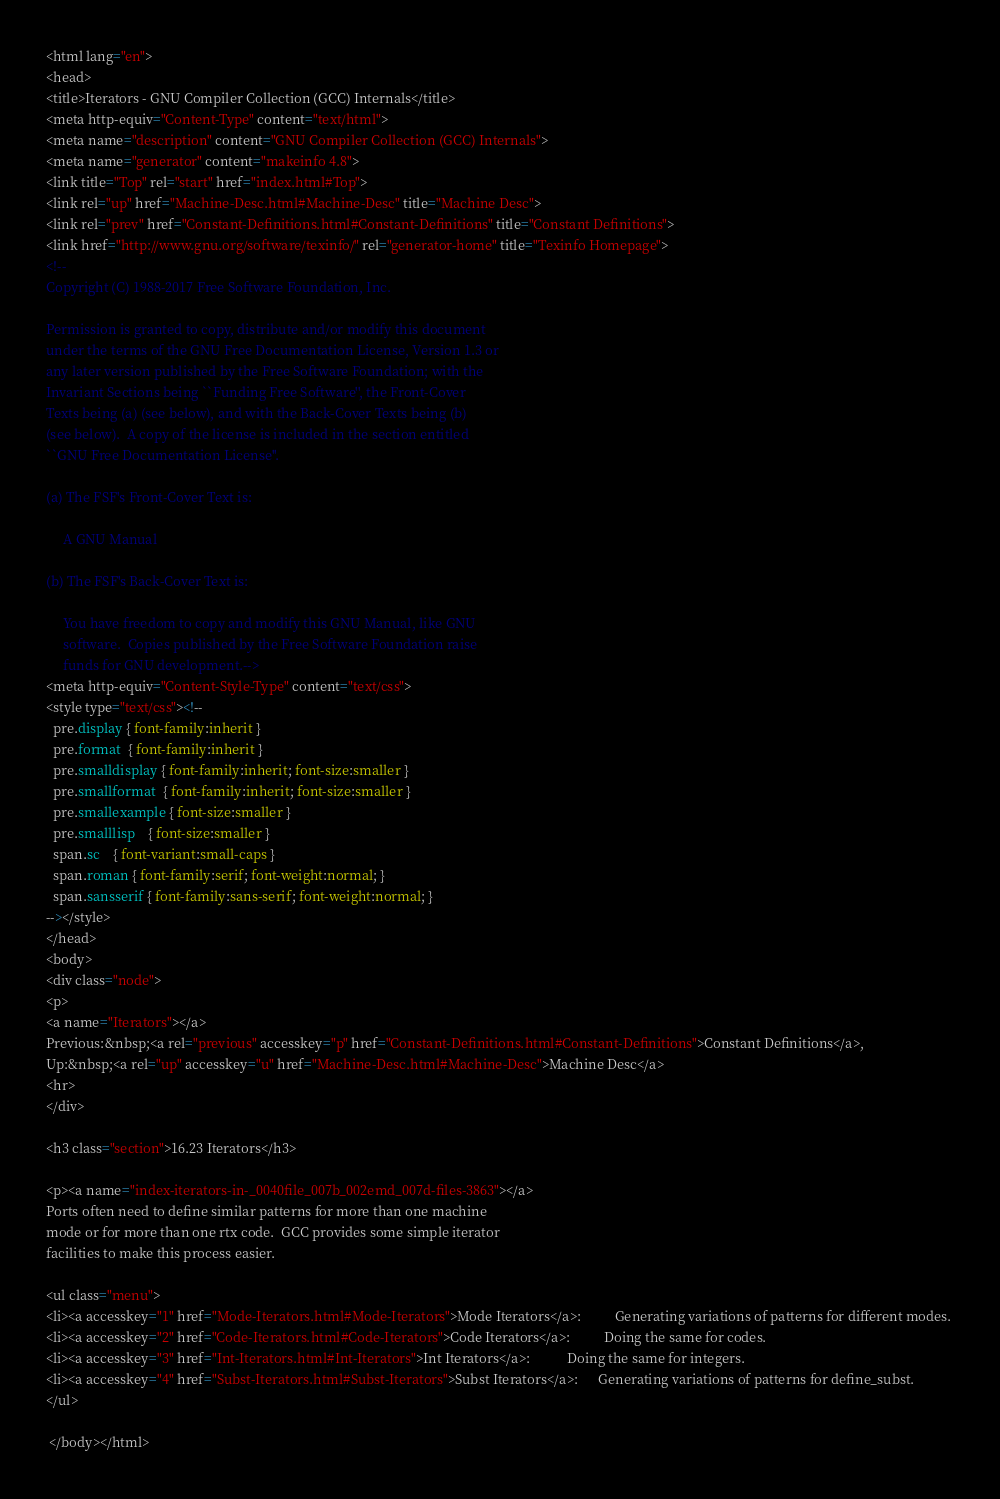<code> <loc_0><loc_0><loc_500><loc_500><_HTML_><html lang="en">
<head>
<title>Iterators - GNU Compiler Collection (GCC) Internals</title>
<meta http-equiv="Content-Type" content="text/html">
<meta name="description" content="GNU Compiler Collection (GCC) Internals">
<meta name="generator" content="makeinfo 4.8">
<link title="Top" rel="start" href="index.html#Top">
<link rel="up" href="Machine-Desc.html#Machine-Desc" title="Machine Desc">
<link rel="prev" href="Constant-Definitions.html#Constant-Definitions" title="Constant Definitions">
<link href="http://www.gnu.org/software/texinfo/" rel="generator-home" title="Texinfo Homepage">
<!--
Copyright (C) 1988-2017 Free Software Foundation, Inc.

Permission is granted to copy, distribute and/or modify this document
under the terms of the GNU Free Documentation License, Version 1.3 or
any later version published by the Free Software Foundation; with the
Invariant Sections being ``Funding Free Software'', the Front-Cover
Texts being (a) (see below), and with the Back-Cover Texts being (b)
(see below).  A copy of the license is included in the section entitled
``GNU Free Documentation License''.

(a) The FSF's Front-Cover Text is:

     A GNU Manual

(b) The FSF's Back-Cover Text is:

     You have freedom to copy and modify this GNU Manual, like GNU
     software.  Copies published by the Free Software Foundation raise
     funds for GNU development.-->
<meta http-equiv="Content-Style-Type" content="text/css">
<style type="text/css"><!--
  pre.display { font-family:inherit }
  pre.format  { font-family:inherit }
  pre.smalldisplay { font-family:inherit; font-size:smaller }
  pre.smallformat  { font-family:inherit; font-size:smaller }
  pre.smallexample { font-size:smaller }
  pre.smalllisp    { font-size:smaller }
  span.sc    { font-variant:small-caps }
  span.roman { font-family:serif; font-weight:normal; } 
  span.sansserif { font-family:sans-serif; font-weight:normal; } 
--></style>
</head>
<body>
<div class="node">
<p>
<a name="Iterators"></a>
Previous:&nbsp;<a rel="previous" accesskey="p" href="Constant-Definitions.html#Constant-Definitions">Constant Definitions</a>,
Up:&nbsp;<a rel="up" accesskey="u" href="Machine-Desc.html#Machine-Desc">Machine Desc</a>
<hr>
</div>

<h3 class="section">16.23 Iterators</h3>

<p><a name="index-iterators-in-_0040file_007b_002emd_007d-files-3863"></a>
Ports often need to define similar patterns for more than one machine
mode or for more than one rtx code.  GCC provides some simple iterator
facilities to make this process easier.

<ul class="menu">
<li><a accesskey="1" href="Mode-Iterators.html#Mode-Iterators">Mode Iterators</a>:          Generating variations of patterns for different modes. 
<li><a accesskey="2" href="Code-Iterators.html#Code-Iterators">Code Iterators</a>:          Doing the same for codes. 
<li><a accesskey="3" href="Int-Iterators.html#Int-Iterators">Int Iterators</a>:           Doing the same for integers. 
<li><a accesskey="4" href="Subst-Iterators.html#Subst-Iterators">Subst Iterators</a>: 	   Generating variations of patterns for define_subst. 
</ul>

 </body></html>

</code> 